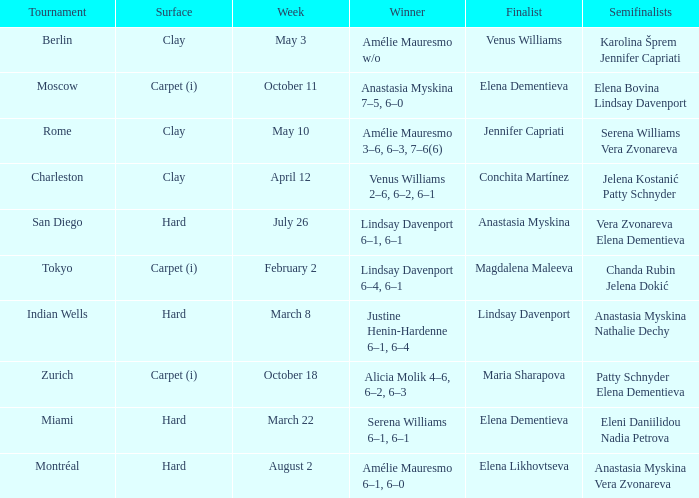Who was the winner of the Miami tournament where Elena Dementieva was a finalist? Serena Williams 6–1, 6–1. 